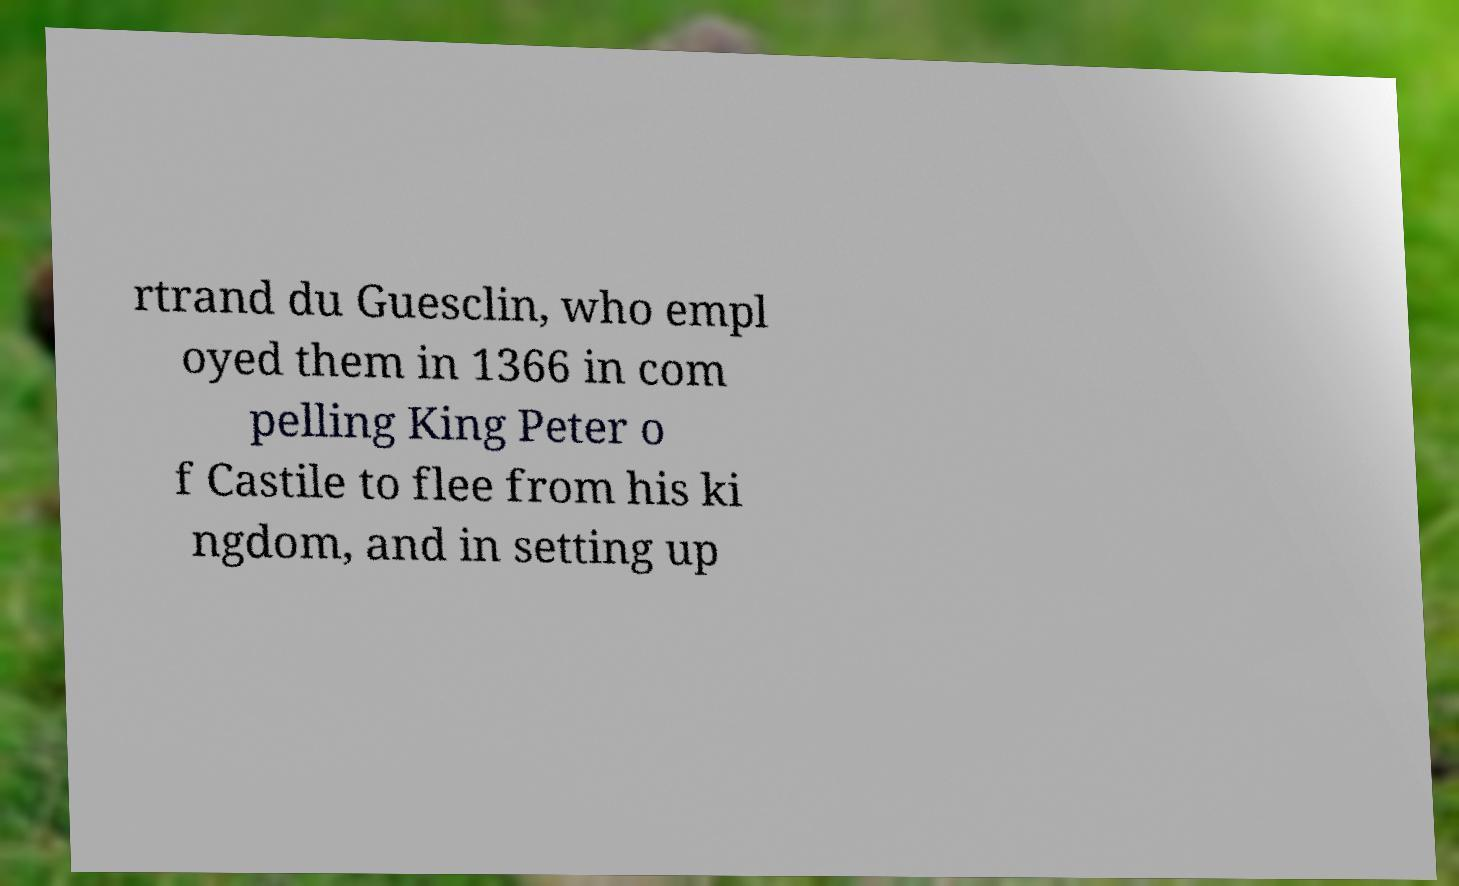Please read and relay the text visible in this image. What does it say? rtrand du Guesclin, who empl oyed them in 1366 in com pelling King Peter o f Castile to flee from his ki ngdom, and in setting up 